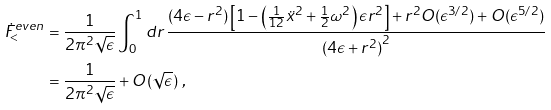Convert formula to latex. <formula><loc_0><loc_0><loc_500><loc_500>\dot { F } ^ { e v e n } _ { < } & = \frac { 1 } { 2 \pi ^ { 2 } \sqrt { \epsilon } } \int _ { 0 } ^ { 1 } d r \, \frac { ( 4 \epsilon - r ^ { 2 } ) \left [ 1 - \left ( \frac { 1 } { 1 2 } { \ddot { x } } ^ { 2 } + \frac { 1 } { 2 } \omega ^ { 2 } \right ) \epsilon r ^ { 2 } \right ] + r ^ { 2 } O ( \epsilon ^ { 3 / 2 } ) + O ( \epsilon ^ { 5 / 2 } ) } { { ( 4 \epsilon + r ^ { 2 } ) } ^ { 2 } } \\ & = \frac { 1 } { 2 \pi ^ { 2 } \sqrt { \epsilon } } + O ( \sqrt { \epsilon } ) \ ,</formula> 